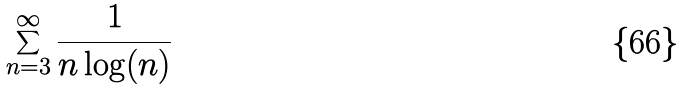Convert formula to latex. <formula><loc_0><loc_0><loc_500><loc_500>\sum _ { n = 3 } ^ { \infty } \frac { 1 } { n \log ( n ) }</formula> 